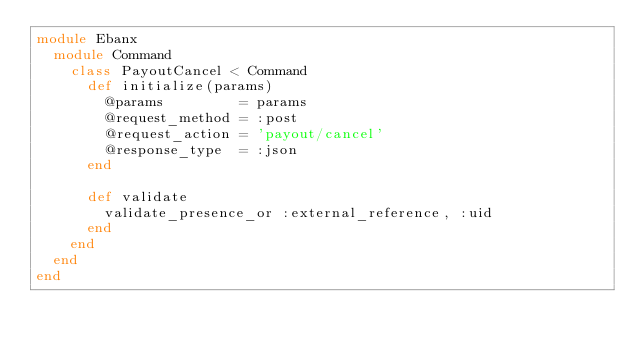Convert code to text. <code><loc_0><loc_0><loc_500><loc_500><_Ruby_>module Ebanx
  module Command
    class PayoutCancel < Command
      def initialize(params)
        @params         = params
        @request_method = :post
        @request_action = 'payout/cancel'
        @response_type  = :json
      end

      def validate
        validate_presence_or :external_reference, :uid
      end
    end
  end
end
</code> 